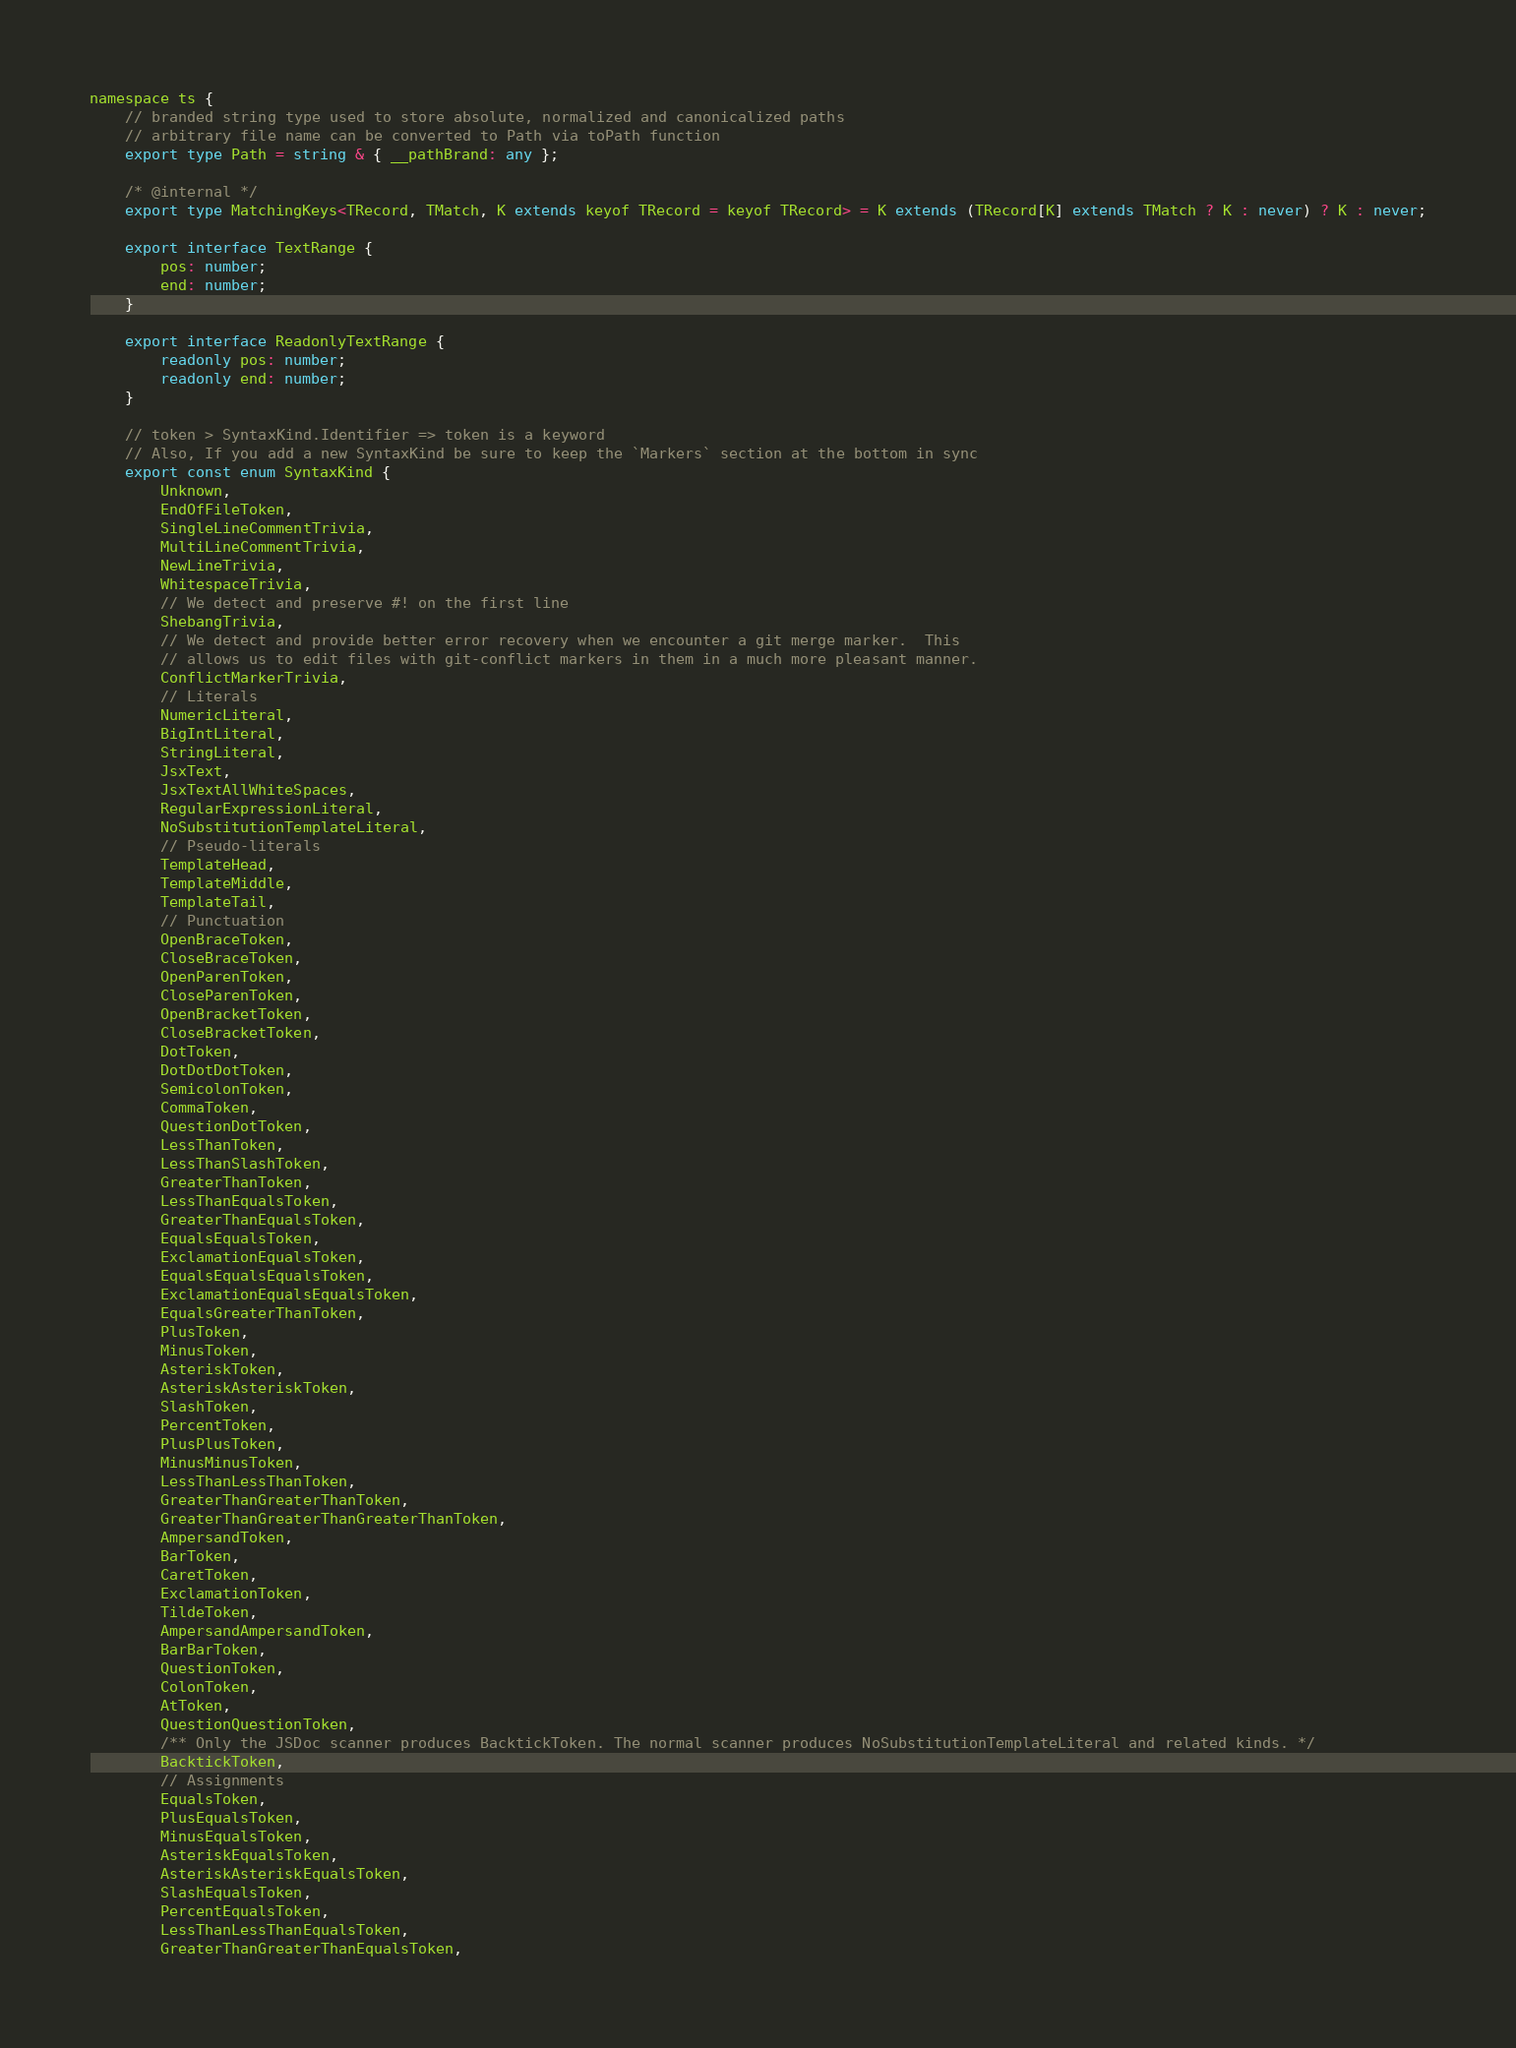Convert code to text. <code><loc_0><loc_0><loc_500><loc_500><_TypeScript_>namespace ts {
    // branded string type used to store absolute, normalized and canonicalized paths
    // arbitrary file name can be converted to Path via toPath function
    export type Path = string & { __pathBrand: any };

    /* @internal */
    export type MatchingKeys<TRecord, TMatch, K extends keyof TRecord = keyof TRecord> = K extends (TRecord[K] extends TMatch ? K : never) ? K : never;

    export interface TextRange {
        pos: number;
        end: number;
    }

    export interface ReadonlyTextRange {
        readonly pos: number;
        readonly end: number;
    }

    // token > SyntaxKind.Identifier => token is a keyword
    // Also, If you add a new SyntaxKind be sure to keep the `Markers` section at the bottom in sync
    export const enum SyntaxKind {
        Unknown,
        EndOfFileToken,
        SingleLineCommentTrivia,
        MultiLineCommentTrivia,
        NewLineTrivia,
        WhitespaceTrivia,
        // We detect and preserve #! on the first line
        ShebangTrivia,
        // We detect and provide better error recovery when we encounter a git merge marker.  This
        // allows us to edit files with git-conflict markers in them in a much more pleasant manner.
        ConflictMarkerTrivia,
        // Literals
        NumericLiteral,
        BigIntLiteral,
        StringLiteral,
        JsxText,
        JsxTextAllWhiteSpaces,
        RegularExpressionLiteral,
        NoSubstitutionTemplateLiteral,
        // Pseudo-literals
        TemplateHead,
        TemplateMiddle,
        TemplateTail,
        // Punctuation
        OpenBraceToken,
        CloseBraceToken,
        OpenParenToken,
        CloseParenToken,
        OpenBracketToken,
        CloseBracketToken,
        DotToken,
        DotDotDotToken,
        SemicolonToken,
        CommaToken,
        QuestionDotToken,
        LessThanToken,
        LessThanSlashToken,
        GreaterThanToken,
        LessThanEqualsToken,
        GreaterThanEqualsToken,
        EqualsEqualsToken,
        ExclamationEqualsToken,
        EqualsEqualsEqualsToken,
        ExclamationEqualsEqualsToken,
        EqualsGreaterThanToken,
        PlusToken,
        MinusToken,
        AsteriskToken,
        AsteriskAsteriskToken,
        SlashToken,
        PercentToken,
        PlusPlusToken,
        MinusMinusToken,
        LessThanLessThanToken,
        GreaterThanGreaterThanToken,
        GreaterThanGreaterThanGreaterThanToken,
        AmpersandToken,
        BarToken,
        CaretToken,
        ExclamationToken,
        TildeToken,
        AmpersandAmpersandToken,
        BarBarToken,
        QuestionToken,
        ColonToken,
        AtToken,
        QuestionQuestionToken,
        /** Only the JSDoc scanner produces BacktickToken. The normal scanner produces NoSubstitutionTemplateLiteral and related kinds. */
        BacktickToken,
        // Assignments
        EqualsToken,
        PlusEqualsToken,
        MinusEqualsToken,
        AsteriskEqualsToken,
        AsteriskAsteriskEqualsToken,
        SlashEqualsToken,
        PercentEqualsToken,
        LessThanLessThanEqualsToken,
        GreaterThanGreaterThanEqualsToken,</code> 